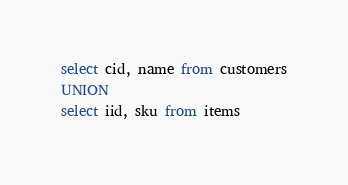Convert code to text. <code><loc_0><loc_0><loc_500><loc_500><_SQL_>select cid, name from customers
UNION
select iid, sku from items</code> 